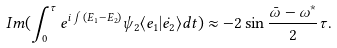Convert formula to latex. <formula><loc_0><loc_0><loc_500><loc_500>I m ( \int _ { 0 } ^ { \tau } e ^ { i \int ( E _ { 1 } - E _ { 2 } ) } \psi _ { 2 } \langle e _ { 1 } | \dot { e _ { 2 } } \rangle d t ) \approx - 2 \sin { \frac { \bar { \omega } - \omega ^ { * } } { 2 } \tau } .</formula> 